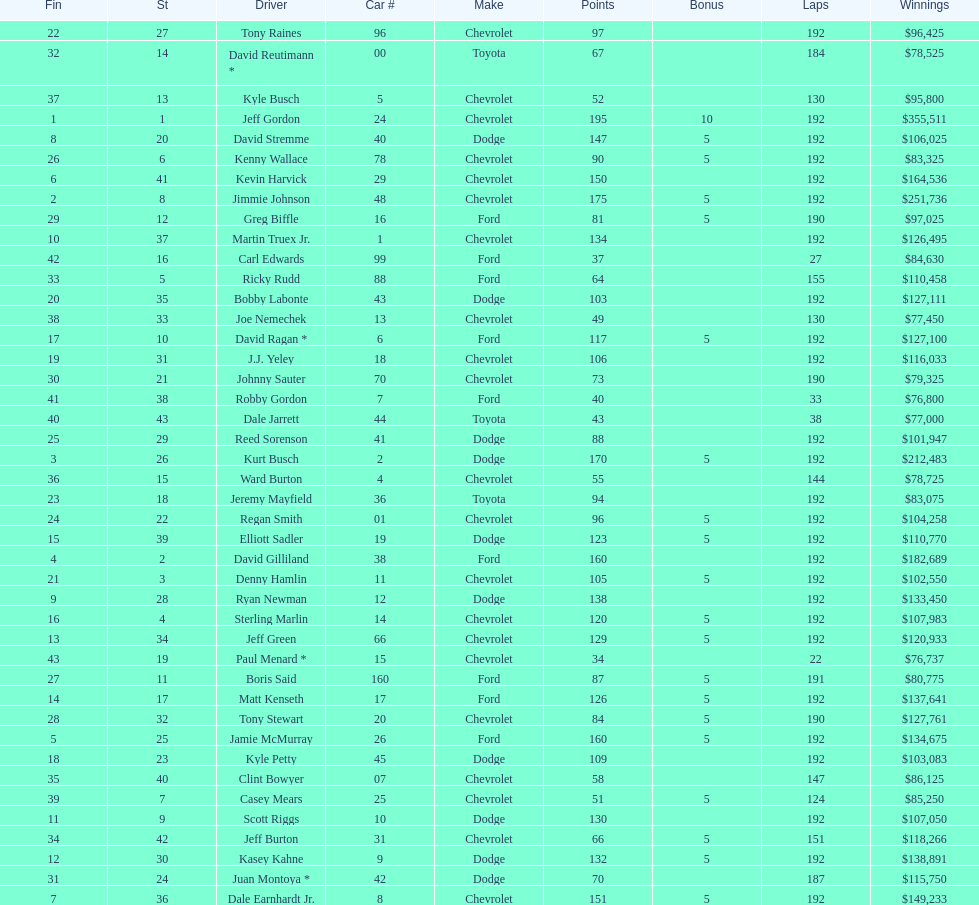How many drivers earned 5 bonus each in the race? 19. 